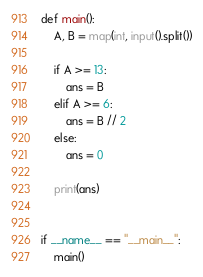<code> <loc_0><loc_0><loc_500><loc_500><_Python_>def main():
    A, B = map(int, input().split())

    if A >= 13:
        ans = B
    elif A >= 6:
        ans = B // 2
    else:
        ans = 0

    print(ans)


if __name__ == "__main__":
    main()
</code> 